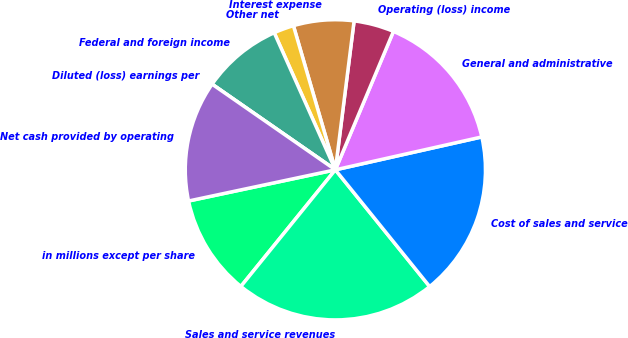<chart> <loc_0><loc_0><loc_500><loc_500><pie_chart><fcel>in millions except per share<fcel>Sales and service revenues<fcel>Cost of sales and service<fcel>General and administrative<fcel>Operating (loss) income<fcel>Interest expense<fcel>Other net<fcel>Federal and foreign income<fcel>Diluted (loss) earnings per<fcel>Net cash provided by operating<nl><fcel>10.83%<fcel>21.65%<fcel>17.7%<fcel>15.16%<fcel>4.33%<fcel>6.5%<fcel>2.17%<fcel>8.66%<fcel>0.0%<fcel>12.99%<nl></chart> 